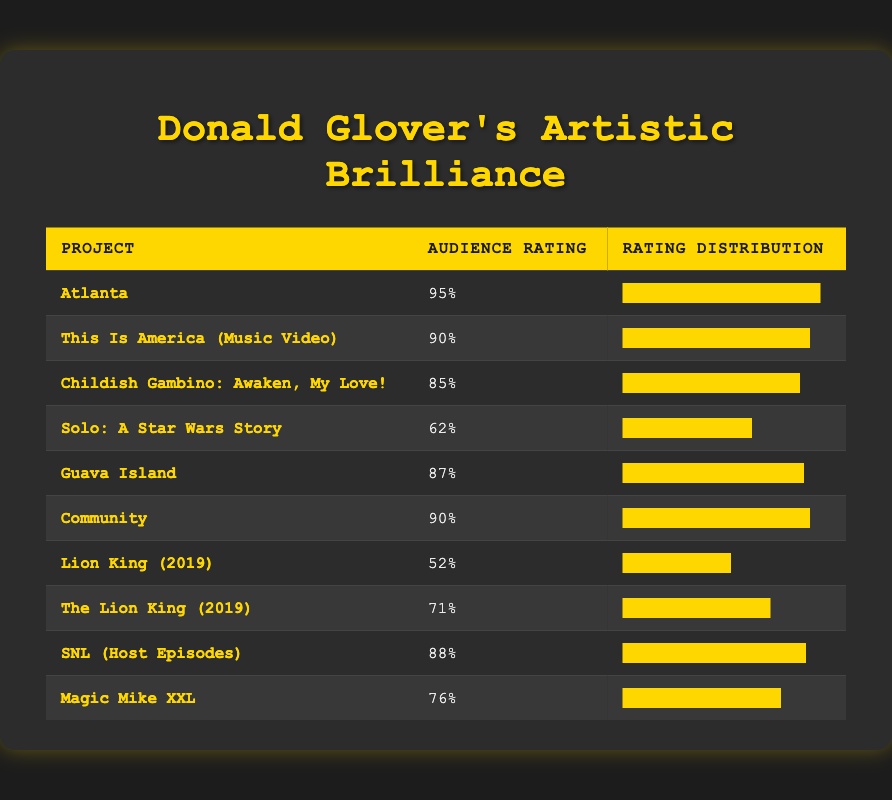What is the audience rating for "Atlanta"? The table lists the audience ratings for various projects, and for "Atlanta," the audience rating is displayed as 95%.
Answer: 95% Which project has the lowest audience rating? Reviewing the audience ratings in the table, the project with the lowest rating is "Lion King (2019)" with a rating of 52%.
Answer: Lion King (2019) What is the average audience rating of Donald Glover's projects listed? To find the average, we sum up the ratings: 95 + 90 + 85 + 62 + 87 + 90 + 52 + 71 + 88 + 76 =  98/10 = 76.2%. Thus, the average rating is 76.2%.
Answer: 76.2% Is "Community" rated higher than "Magic Mike XXL"? The audience rating for "Community" is 90%, while "Magic Mike XXL" has a rating of 76%. Since 90% is greater than 76%, the statement is true.
Answer: Yes Which two projects have the same audience rating, and what is that rating? Both "This Is America (Music Video)" and "Community" have ratings of 90%. This can be seen in the table under audience rating.
Answer: 90% (This Is America (Music Video), Community) What is the difference in audience ratings between "Awaken, My Love!" and "Guava Island"? The audience rating for "Awaken, My Love!" is 85%, while "Guava Island" has a rating of 87%. The difference is 87% - 85% = 2%.
Answer: 2% How many projects are rated above 80%? From the list, we can see that the projects "Atlanta," "This Is America (Music Video)," "Childish Gambino: Awaken, My Love!," "Guava Island," "Community," "SNL (Host Episodes)" all have ratings above 80%. Counting these gives us 6 projects.
Answer: 6 Are there any projects that received an audience rating below 60%? The table shows that "Lion King (2019)" and "Solo: A Star Wars Story" have ratings of 52% and 62% respectively. Since "Lion King (2019)" is below 60%, the answer is yes.
Answer: Yes Which project has a rating of 88%? Looking at the table, "SNL (Host Episodes)" is listed as having an audience rating of 88%.
Answer: SNL (Host Episodes) 